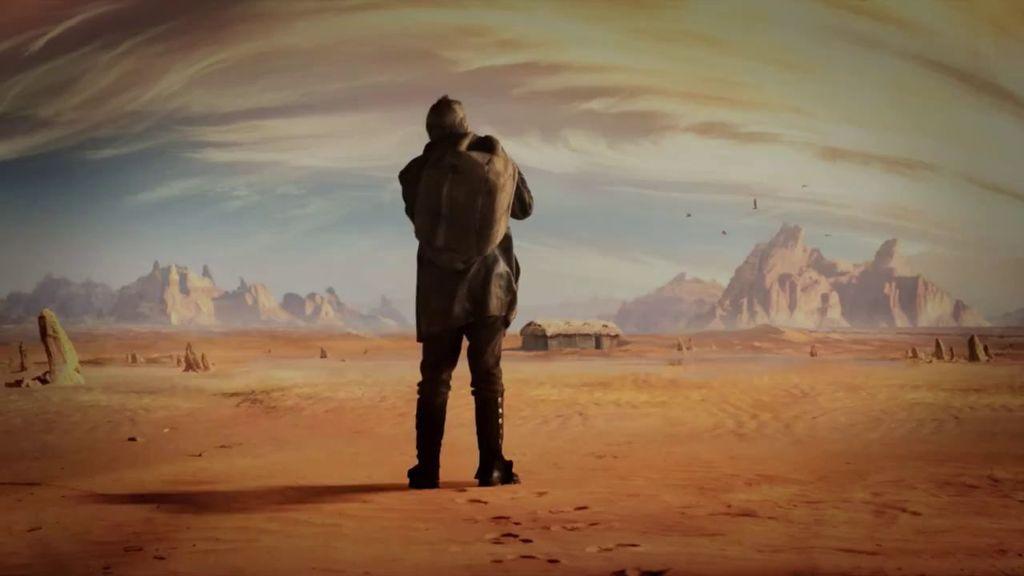Can you describe this image briefly? This image is an edited image. At the top of the image there is the sky with clouds and there are a few birds. In the background there are a few hills and rocks. There is a hut. In the middle of the image a man is standing on the ground. At the bottom of the image there is a ground. 